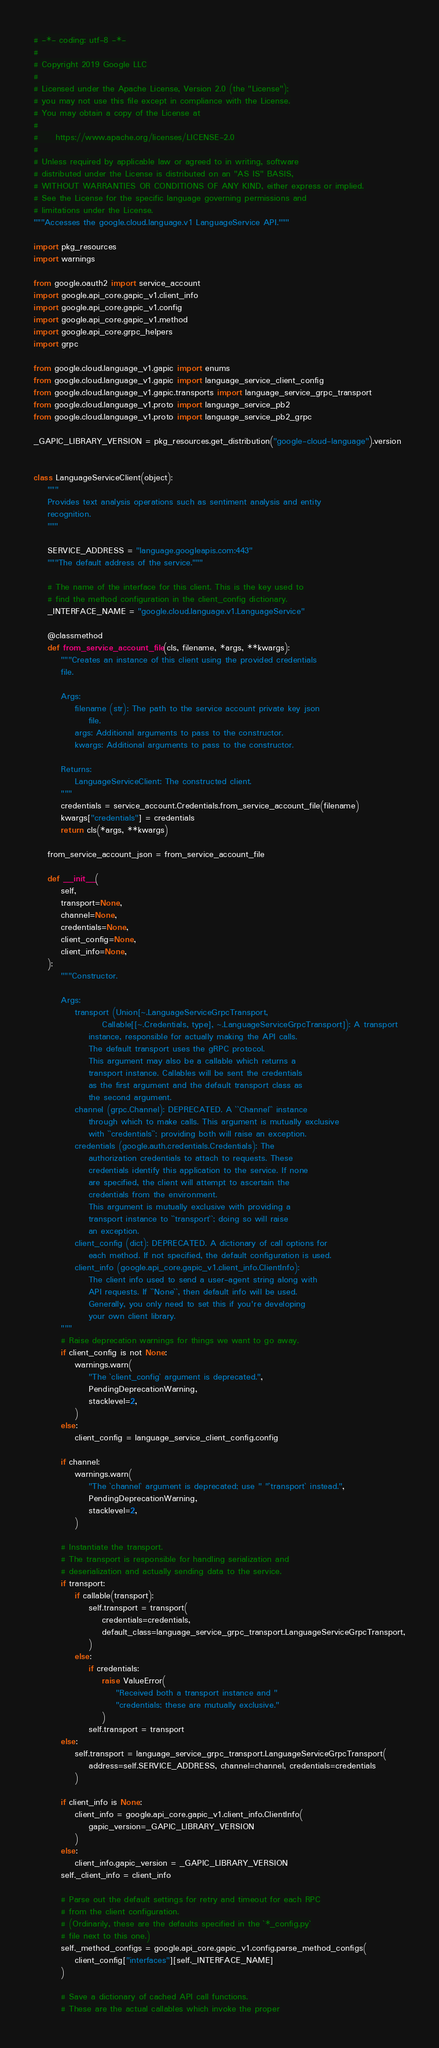Convert code to text. <code><loc_0><loc_0><loc_500><loc_500><_Python_># -*- coding: utf-8 -*-
#
# Copyright 2019 Google LLC
#
# Licensed under the Apache License, Version 2.0 (the "License");
# you may not use this file except in compliance with the License.
# You may obtain a copy of the License at
#
#     https://www.apache.org/licenses/LICENSE-2.0
#
# Unless required by applicable law or agreed to in writing, software
# distributed under the License is distributed on an "AS IS" BASIS,
# WITHOUT WARRANTIES OR CONDITIONS OF ANY KIND, either express or implied.
# See the License for the specific language governing permissions and
# limitations under the License.
"""Accesses the google.cloud.language.v1 LanguageService API."""

import pkg_resources
import warnings

from google.oauth2 import service_account
import google.api_core.gapic_v1.client_info
import google.api_core.gapic_v1.config
import google.api_core.gapic_v1.method
import google.api_core.grpc_helpers
import grpc

from google.cloud.language_v1.gapic import enums
from google.cloud.language_v1.gapic import language_service_client_config
from google.cloud.language_v1.gapic.transports import language_service_grpc_transport
from google.cloud.language_v1.proto import language_service_pb2
from google.cloud.language_v1.proto import language_service_pb2_grpc

_GAPIC_LIBRARY_VERSION = pkg_resources.get_distribution("google-cloud-language").version


class LanguageServiceClient(object):
    """
    Provides text analysis operations such as sentiment analysis and entity
    recognition.
    """

    SERVICE_ADDRESS = "language.googleapis.com:443"
    """The default address of the service."""

    # The name of the interface for this client. This is the key used to
    # find the method configuration in the client_config dictionary.
    _INTERFACE_NAME = "google.cloud.language.v1.LanguageService"

    @classmethod
    def from_service_account_file(cls, filename, *args, **kwargs):
        """Creates an instance of this client using the provided credentials
        file.

        Args:
            filename (str): The path to the service account private key json
                file.
            args: Additional arguments to pass to the constructor.
            kwargs: Additional arguments to pass to the constructor.

        Returns:
            LanguageServiceClient: The constructed client.
        """
        credentials = service_account.Credentials.from_service_account_file(filename)
        kwargs["credentials"] = credentials
        return cls(*args, **kwargs)

    from_service_account_json = from_service_account_file

    def __init__(
        self,
        transport=None,
        channel=None,
        credentials=None,
        client_config=None,
        client_info=None,
    ):
        """Constructor.

        Args:
            transport (Union[~.LanguageServiceGrpcTransport,
                    Callable[[~.Credentials, type], ~.LanguageServiceGrpcTransport]): A transport
                instance, responsible for actually making the API calls.
                The default transport uses the gRPC protocol.
                This argument may also be a callable which returns a
                transport instance. Callables will be sent the credentials
                as the first argument and the default transport class as
                the second argument.
            channel (grpc.Channel): DEPRECATED. A ``Channel`` instance
                through which to make calls. This argument is mutually exclusive
                with ``credentials``; providing both will raise an exception.
            credentials (google.auth.credentials.Credentials): The
                authorization credentials to attach to requests. These
                credentials identify this application to the service. If none
                are specified, the client will attempt to ascertain the
                credentials from the environment.
                This argument is mutually exclusive with providing a
                transport instance to ``transport``; doing so will raise
                an exception.
            client_config (dict): DEPRECATED. A dictionary of call options for
                each method. If not specified, the default configuration is used.
            client_info (google.api_core.gapic_v1.client_info.ClientInfo):
                The client info used to send a user-agent string along with
                API requests. If ``None``, then default info will be used.
                Generally, you only need to set this if you're developing
                your own client library.
        """
        # Raise deprecation warnings for things we want to go away.
        if client_config is not None:
            warnings.warn(
                "The `client_config` argument is deprecated.",
                PendingDeprecationWarning,
                stacklevel=2,
            )
        else:
            client_config = language_service_client_config.config

        if channel:
            warnings.warn(
                "The `channel` argument is deprecated; use " "`transport` instead.",
                PendingDeprecationWarning,
                stacklevel=2,
            )

        # Instantiate the transport.
        # The transport is responsible for handling serialization and
        # deserialization and actually sending data to the service.
        if transport:
            if callable(transport):
                self.transport = transport(
                    credentials=credentials,
                    default_class=language_service_grpc_transport.LanguageServiceGrpcTransport,
                )
            else:
                if credentials:
                    raise ValueError(
                        "Received both a transport instance and "
                        "credentials; these are mutually exclusive."
                    )
                self.transport = transport
        else:
            self.transport = language_service_grpc_transport.LanguageServiceGrpcTransport(
                address=self.SERVICE_ADDRESS, channel=channel, credentials=credentials
            )

        if client_info is None:
            client_info = google.api_core.gapic_v1.client_info.ClientInfo(
                gapic_version=_GAPIC_LIBRARY_VERSION
            )
        else:
            client_info.gapic_version = _GAPIC_LIBRARY_VERSION
        self._client_info = client_info

        # Parse out the default settings for retry and timeout for each RPC
        # from the client configuration.
        # (Ordinarily, these are the defaults specified in the `*_config.py`
        # file next to this one.)
        self._method_configs = google.api_core.gapic_v1.config.parse_method_configs(
            client_config["interfaces"][self._INTERFACE_NAME]
        )

        # Save a dictionary of cached API call functions.
        # These are the actual callables which invoke the proper</code> 